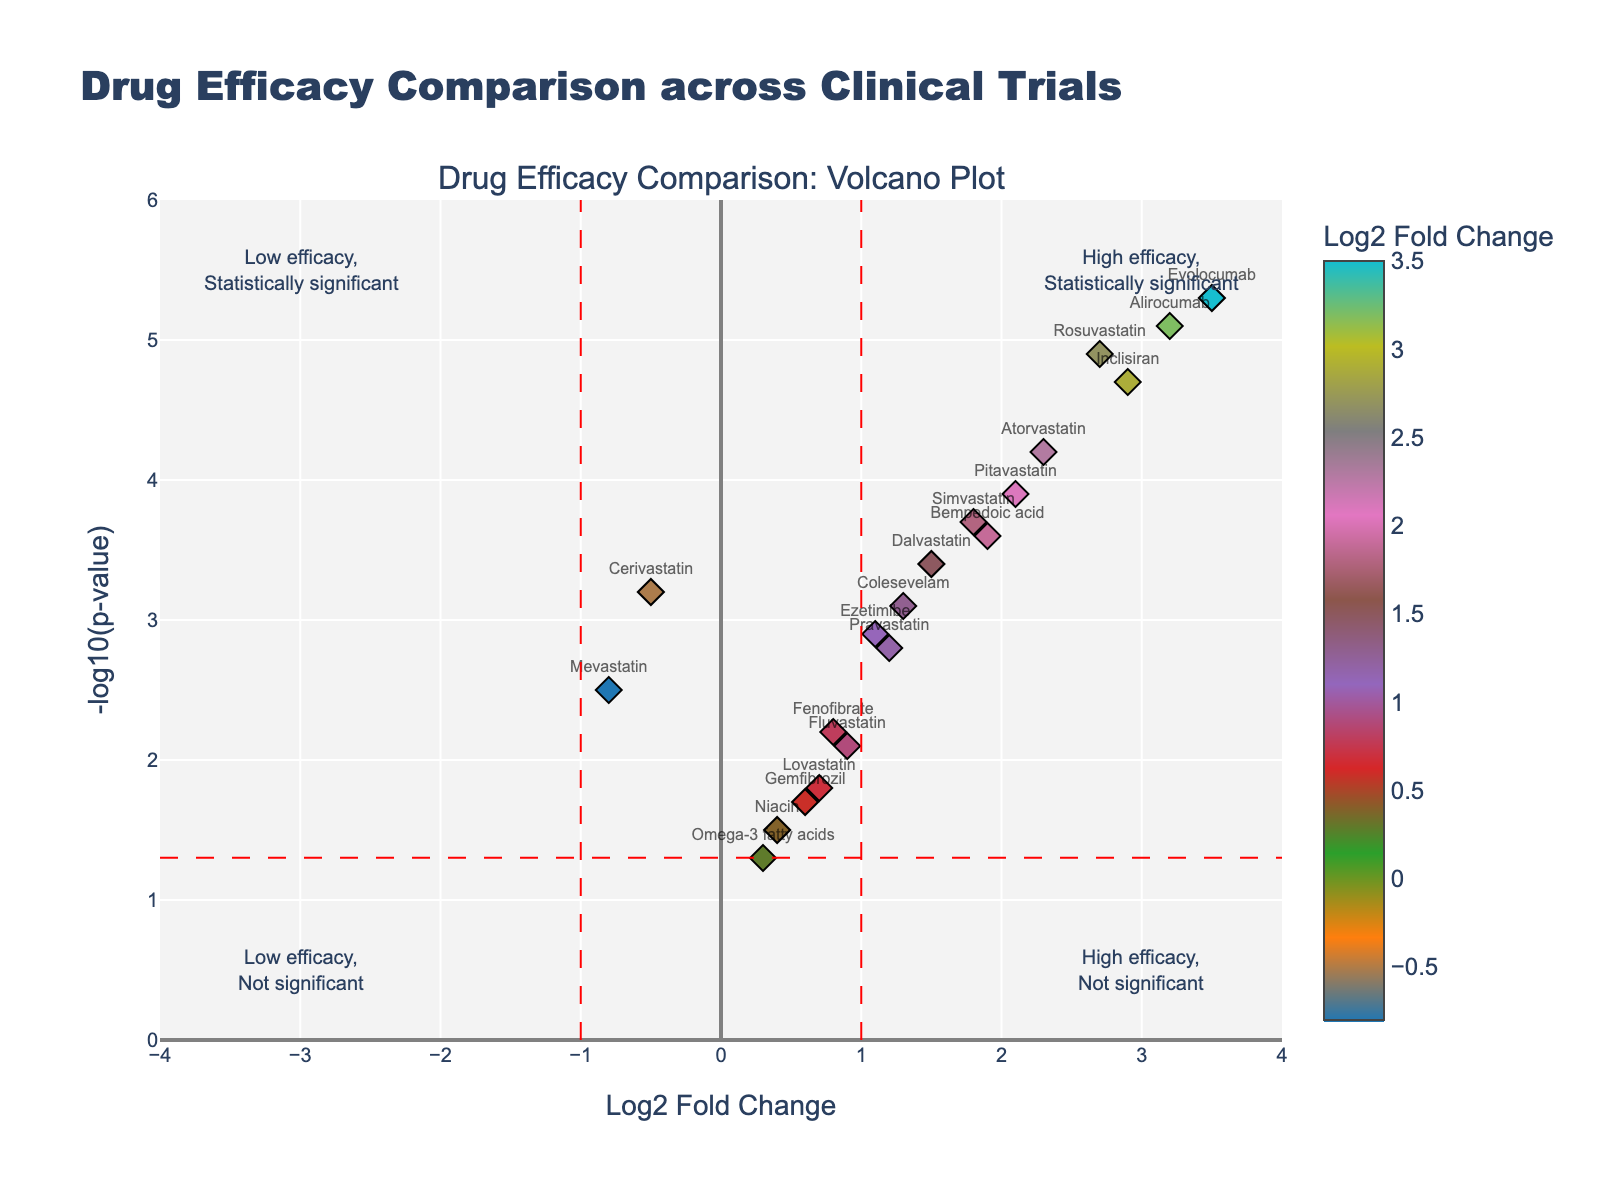Which drug has the highest Log2 Fold Change? The drug with the highest Log2 Fold Change is the one with the largest value on the x-axis. Evolocumab has the highest value at 3.5.
Answer: Evolocumab Which drug has the highest statistical significance? The drug with the highest statistical significance has the highest value on the y-axis. Evolocumab has the highest -log10(p-value) at 5.3.
Answer: Evolocumab Which drugs fall into the "High efficacy, Statistically significant" quadrant? Drugs in this quadrant have a Log2 Fold Change>1 and -log10(p-value)>1. The drugs in this quadrant are Atorvastatin, Rosuvastatin, Pitavastatin, Alirocumab, Evolocumab, and Inclisiran.
Answer: Atorvastatin, Rosuvastatin, Pitavastatin, Alirocumab, Evolocumab, Inclisiran Which drugs fall into the "Low efficacy, Statistically significant" quadrant? Drugs in this quadrant have a Log2 Fold Change<-1 and -log10(p-value)>1. The only drug in this quadrant is Cerivastatin.
Answer: Cerivastatin How many drugs have a Log2 Fold Change greater than 2? Count the data points that have a Log2 Fold Change greater than 2. The drugs meeting this criterion are Atorvastatin, Rosuvastatin, Alirocumab, Evolocumab, and Inclisiran.
Answer: 5 Which drug has the lowest efficacy but statistically significant results? The drug with the lowest efficacy (lowest Log2 Fold Change) and statistically significant results (high -log10(p-value)) is Cerivastatin with a Log2 Fold Change of -0.5 and a -log10(p-value) of 3.2.
Answer: Cerivastatin Compare the efficacy between Atorvastatin and Simvastatin. Which one has higher efficacy? Atorvastatin has a Log2 Fold Change of 2.3 and Simvastatin has a Log2 Fold Change of 1.8. Since 2.3>1.8, Atorvastatin has higher efficacy.
Answer: Atorvastatin What is the quadrant for drugs with a high efficacy but not statistically significant? Drugs in this quadrant have a Log2 Fold Change>1 and -log10(p-value)<1. There are no drugs in this quadrant as all drugs have -log10(p-value) higher than 1.
Answer: None Among the drugs with a Log2 Fold Change below 1, which drug is the most statistically significant? Among the drugs with Log2 Fold Change below 1, Fluvastatin has the highest -log10(p-value) at 2.1.
Answer: Fluvastatin How many drugs fall in the “High efficacy, Statistically significant” quadrant? Count the data points in the “High efficacy, Statistically significant” quadrant, which are drugs with Log2 Fold Change>1 and -log10(p-value)>1. There are 6 drugs in this quadrant: Atorvastatin, Rosuvastatin, Pitavastatin, Alirocumab, Evolocumab, and Inclisiran.
Answer: 6 